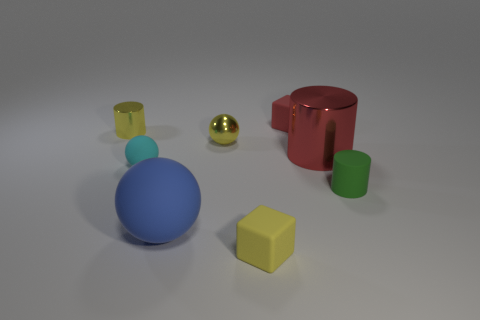Add 1 tiny brown shiny spheres. How many objects exist? 9 Subtract all spheres. How many objects are left? 5 Add 5 yellow balls. How many yellow balls are left? 6 Add 1 big purple rubber blocks. How many big purple rubber blocks exist? 1 Subtract 0 green cubes. How many objects are left? 8 Subtract all large blue matte objects. Subtract all yellow objects. How many objects are left? 4 